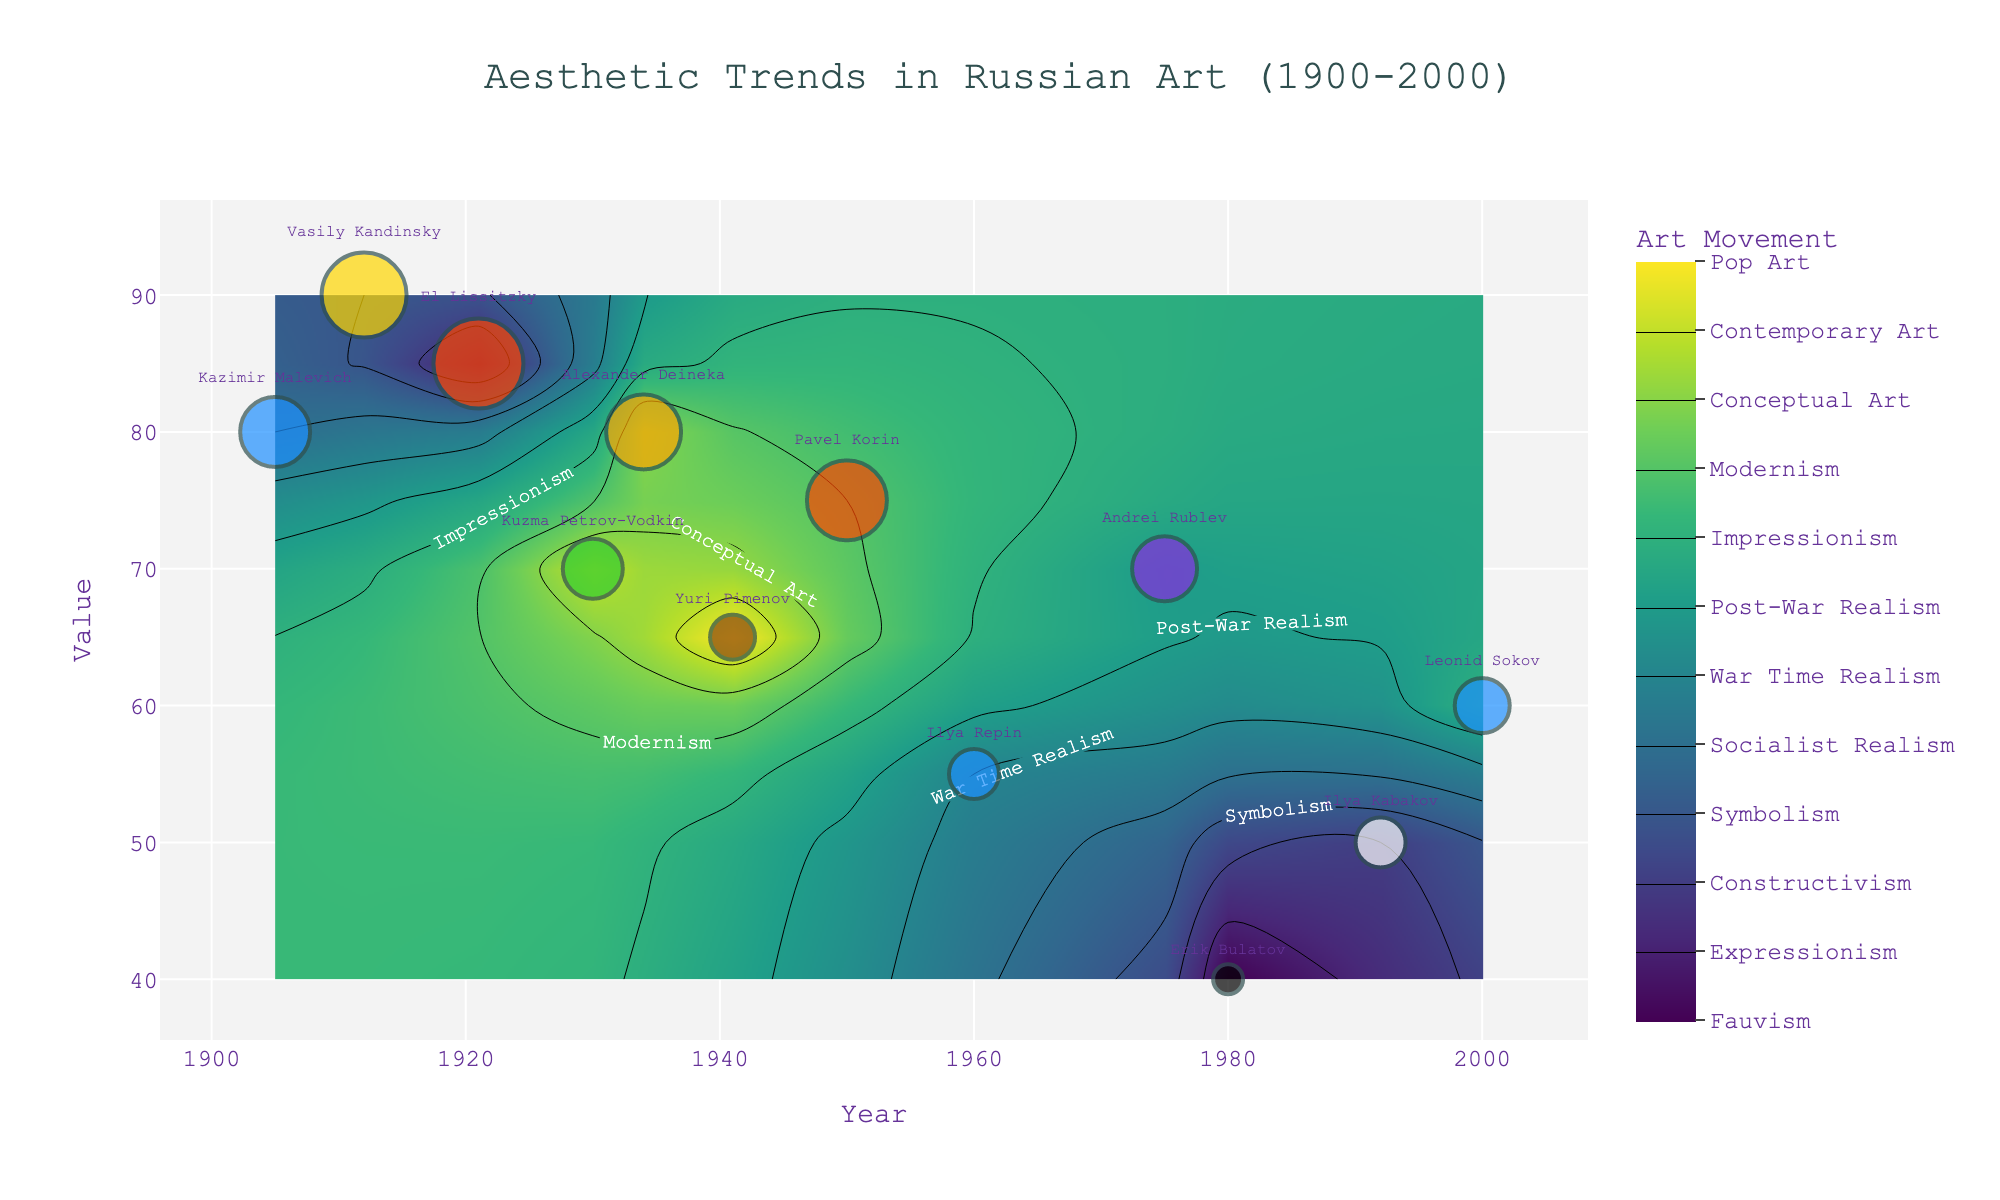What's the title of the plot? The title is displayed at the top of the figure, and it reads "Aesthetic Trends in Russian Art (1900-2000)."
Answer: Aesthetic Trends in Russian Art (1900-2000) What's the primary color used by Kazimir Malevich in 1905? Hover over the marker for Kazimir Malevich in 1905. The tooltip reveals that the primary color is listed as "Blue."
Answer: Blue Which years are shown on the x-axis? The x-axis ranges from 1900 to 2000, as indicated by the tick labels and markers on the axis.
Answer: 1900 to 2000 What is the primary color with the highest saturation as shown in the figure? Look for the marker with the largest size (indicative of high saturation). The text next to this large marker or its hover text shows that the color is "Red," used in 1921 by El Lissitzky.
Answer: Red How many different art movements are represented in the contour plot? The color bar on the right side has ticks that represent each art movement, and there are 11 unique movements listed.
Answer: 11 Which artist used the color Green and what was its Value? Hover over the marker that is colored green. The tooltip reveals that Kuzma Petrov-Vodkin used the color green in 1930, and the Value is 70.
Answer: Kuzma Petrov-Vodkin, 70 Between 1960 and 1980, which year shows the lowest Value, and who is the artist? Locate the markers between 1960 and 1980, and identify the marker positioned lowest on the y-axis. The lowest marker is for Erik Bulatov in 1980, with a Value of 40.
Answer: 1980, Erik Bulatov Compare the Saturation of artists in 1934 and 1992. Which artist uses a higher Saturation, and what are the values? Hover over the markers for 1934 and 1992, and the tooltips provide the Saturation values. Alexander Deineka in 1934 has a Saturation of 75, while Ilya Kabakov in 1992 has a Saturation of 50. Alexander Deineka uses a higher Saturation.
Answer: Alexander Deineka, 75 vs. Ilya Kabakov, 50 What is the average Value of artworks created between 1941 and 2000? Identify and sum the Values of artworks from 1941, 1950, 1960, 1975, 1980, 1992, and 2000 (65, 75, 55, 70, 40, 50, and 60), then divide by the number of these values: (65+75+55+70+40+50+60)/7 = 59.29 (rounded to two decimal places).
Answer: 59.29 Which Primary_Color was used most frequently among the listed artworks? By reviewing the colors used by all artists, note that the color Blue appears three times, the highest frequency.
Answer: Blue 